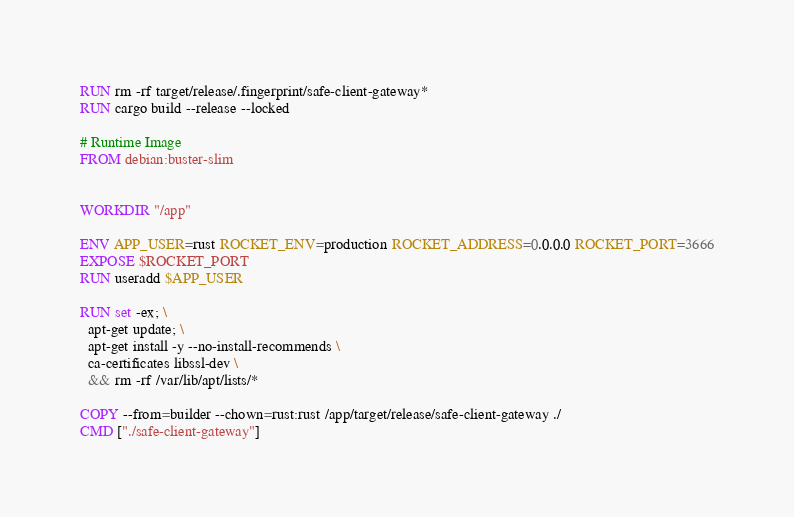<code> <loc_0><loc_0><loc_500><loc_500><_Dockerfile_>RUN rm -rf target/release/.fingerprint/safe-client-gateway*
RUN cargo build --release --locked

# Runtime Image
FROM debian:buster-slim


WORKDIR "/app"

ENV APP_USER=rust ROCKET_ENV=production ROCKET_ADDRESS=0.0.0.0 ROCKET_PORT=3666
EXPOSE $ROCKET_PORT
RUN useradd $APP_USER

RUN set -ex; \ 
  apt-get update; \
  apt-get install -y --no-install-recommends \
  ca-certificates libssl-dev \
  && rm -rf /var/lib/apt/lists/*

COPY --from=builder --chown=rust:rust /app/target/release/safe-client-gateway ./
CMD ["./safe-client-gateway"]
</code> 